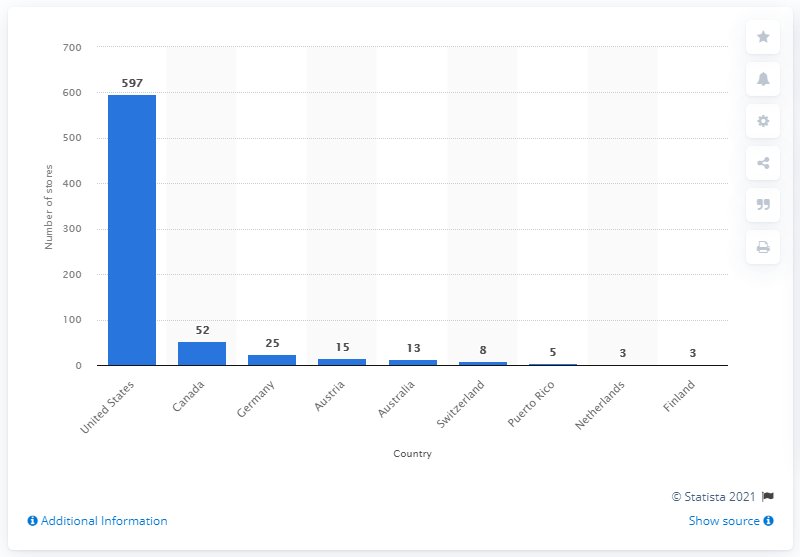List a handful of essential elements in this visual. As of January 30, 2021, there were 52 Zumiez stores in Canada. 